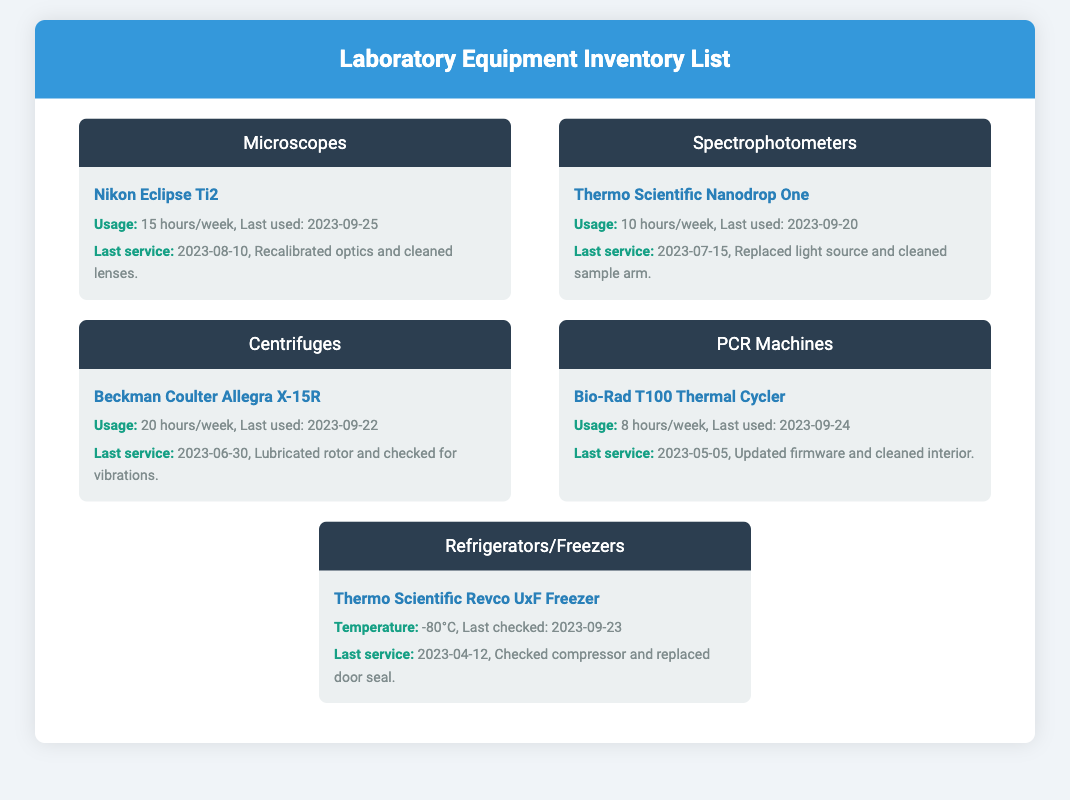What is the usage of the Nikon Eclipse Ti2? The usage statistics indicate it is used for 15 hours per week.
Answer: 15 hours/week When was the last service for the Thermo Scientific Nanodrop One? The maintenance log states that the last service was on 2023-07-15.
Answer: 2023-07-15 How often is the Beckman Coulter Allegra X-15R used? The document specifies its usage as 20 hours per week.
Answer: 20 hours/week What maintenance was done on the Bio-Rad T100 Thermal Cycler during its last service? The last service involved updating firmware and cleaning the interior.
Answer: Updated firmware and cleaned interior What is the temperature setting of the Thermo Scientific Revco UxF Freezer? The document states the temperature is set at -80°C.
Answer: -80°C Which equipment category includes the instrument used for thermal cycling? The Bio-Rad T100 Thermal Cycler falls under the PCR Machines category.
Answer: PCR Machines What action was taken on the centrifuge during its last maintenance? During the last service, the rotor was lubricated and checked for vibrations.
Answer: Lubricated rotor and checked for vibrations When was the Nikon Eclipse Ti2 last used? The usage log records that it was last used on 2023-09-25.
Answer: 2023-09-25 